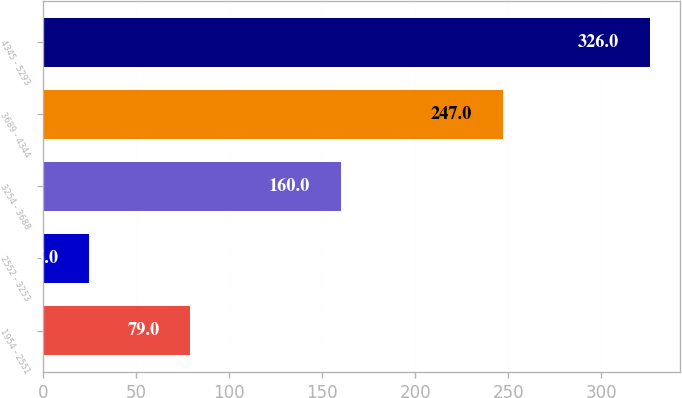Convert chart to OTSL. <chart><loc_0><loc_0><loc_500><loc_500><bar_chart><fcel>1954 - 2551<fcel>2552 - 3253<fcel>3254 - 3688<fcel>3689 - 4344<fcel>4345 - 5293<nl><fcel>79<fcel>25<fcel>160<fcel>247<fcel>326<nl></chart> 